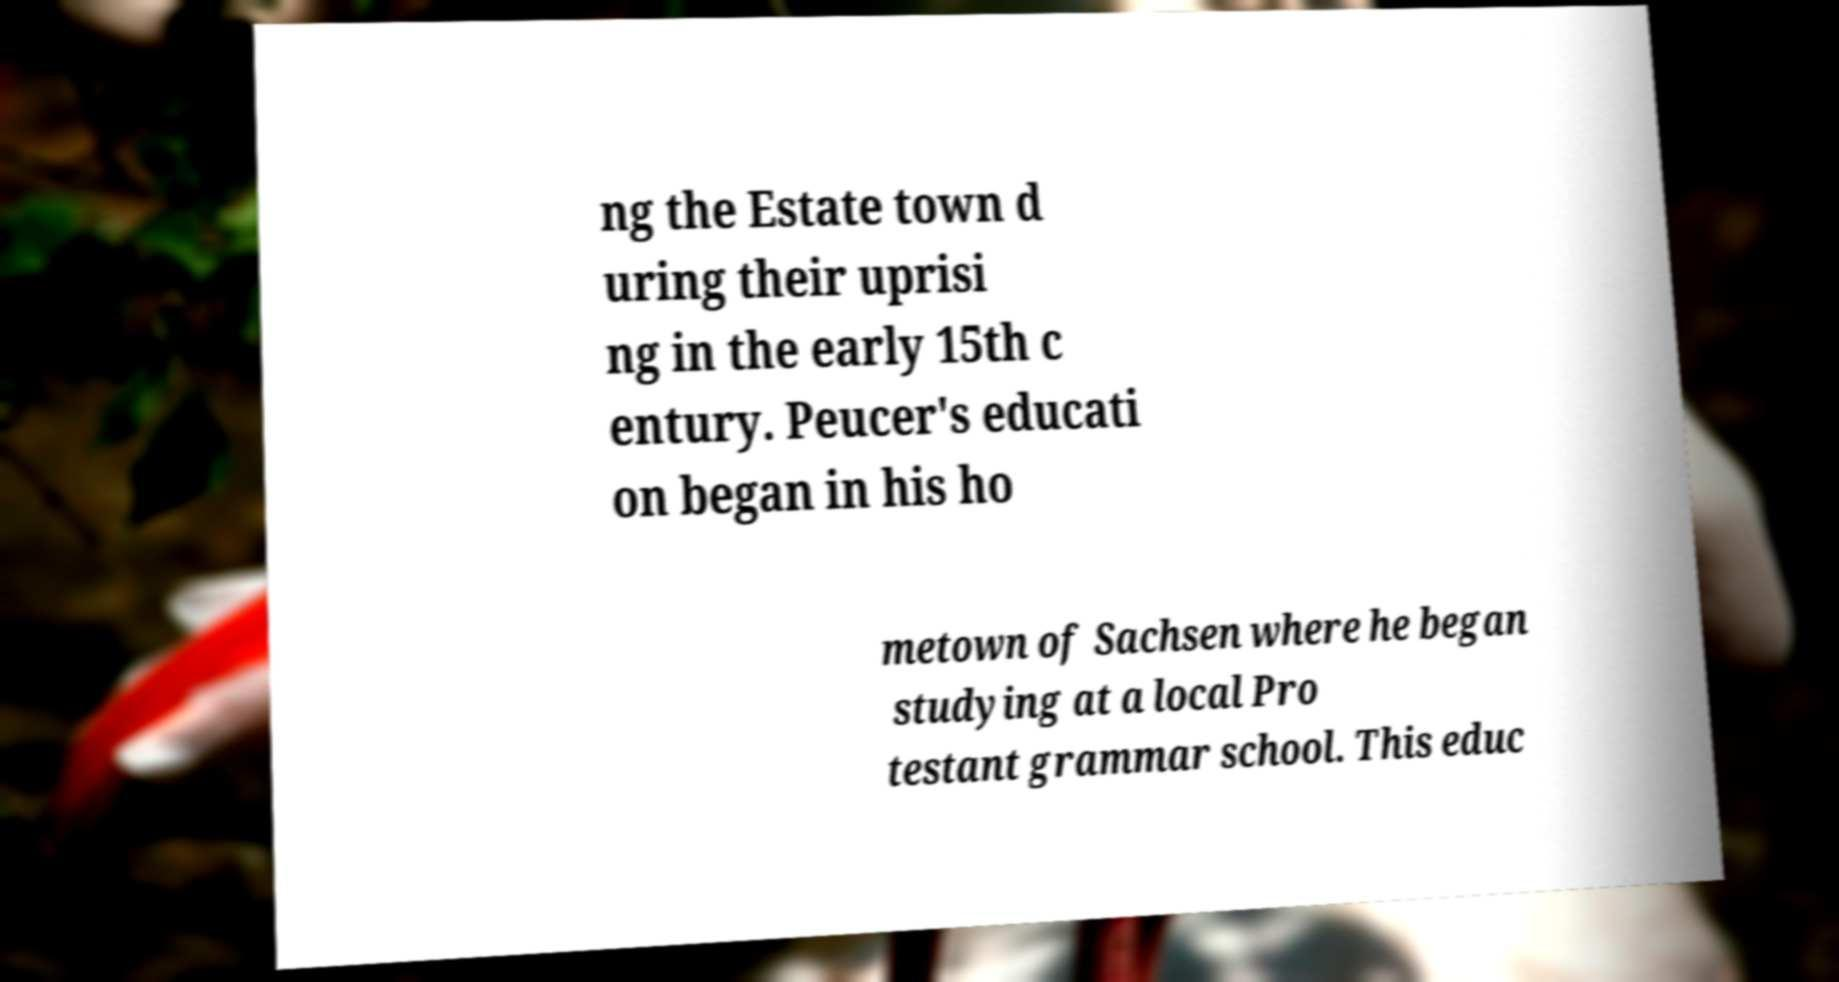Could you extract and type out the text from this image? ng the Estate town d uring their uprisi ng in the early 15th c entury. Peucer's educati on began in his ho metown of Sachsen where he began studying at a local Pro testant grammar school. This educ 